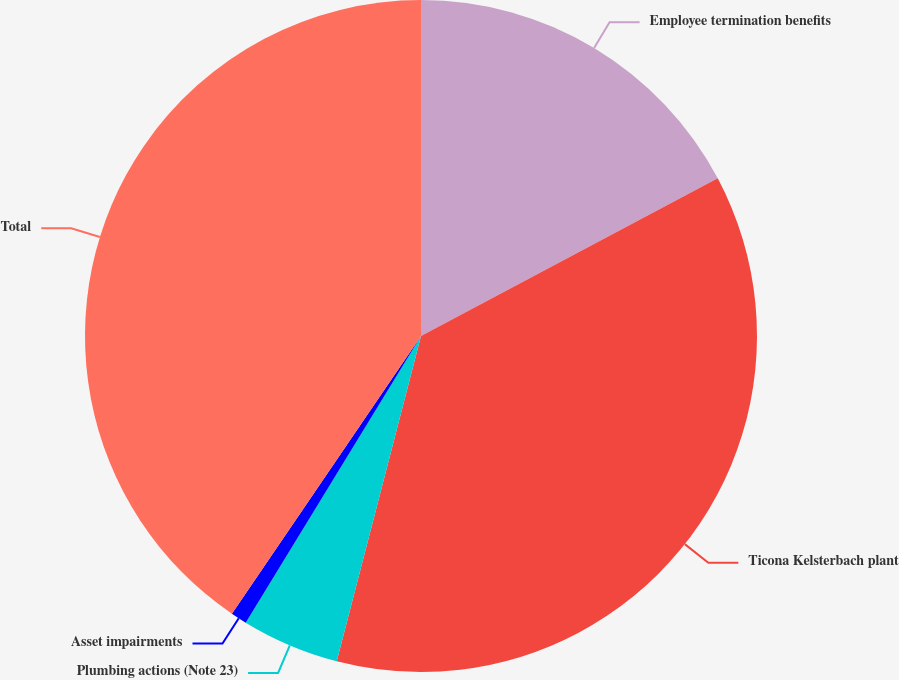Convert chart. <chart><loc_0><loc_0><loc_500><loc_500><pie_chart><fcel>Employee termination benefits<fcel>Ticona Kelsterbach plant<fcel>Plumbing actions (Note 23)<fcel>Asset impairments<fcel>Total<nl><fcel>17.23%<fcel>36.81%<fcel>4.7%<fcel>0.78%<fcel>40.49%<nl></chart> 